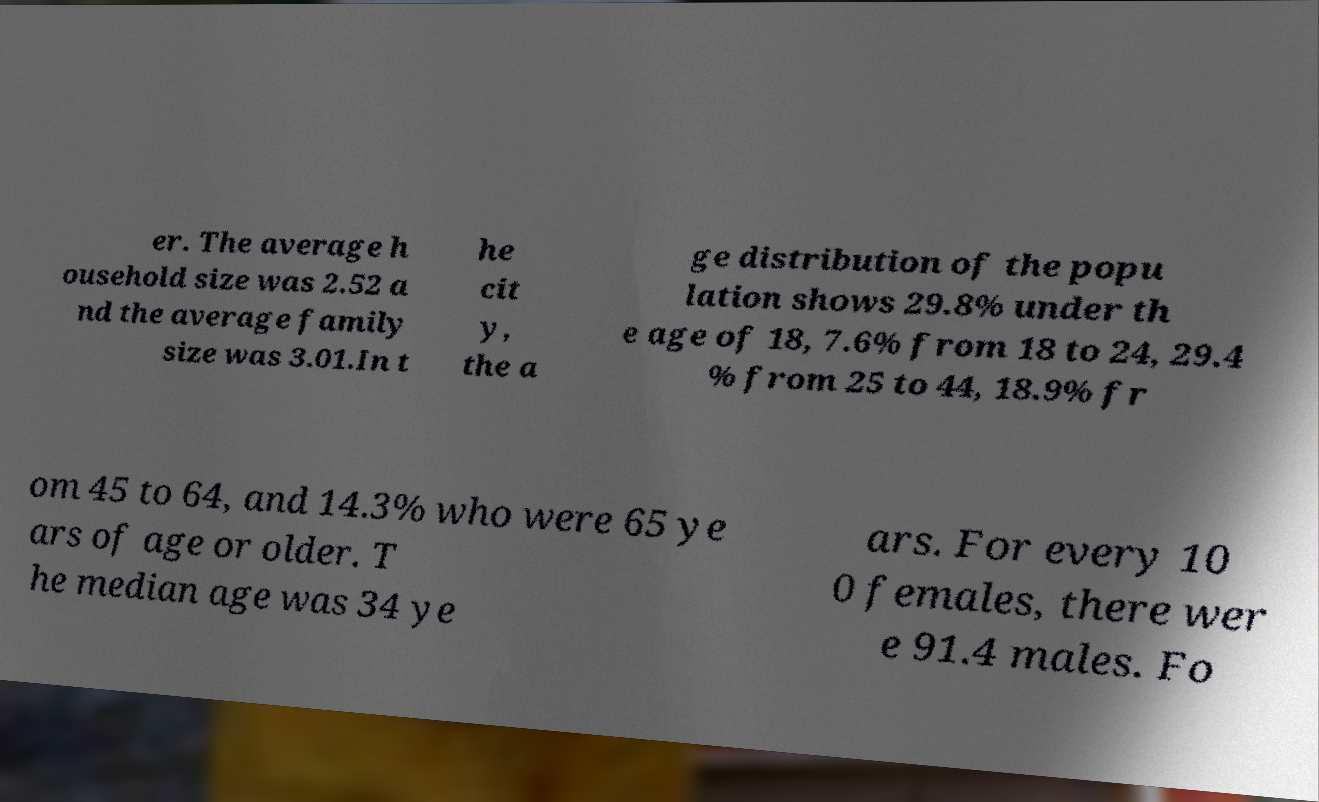Can you read and provide the text displayed in the image?This photo seems to have some interesting text. Can you extract and type it out for me? er. The average h ousehold size was 2.52 a nd the average family size was 3.01.In t he cit y, the a ge distribution of the popu lation shows 29.8% under th e age of 18, 7.6% from 18 to 24, 29.4 % from 25 to 44, 18.9% fr om 45 to 64, and 14.3% who were 65 ye ars of age or older. T he median age was 34 ye ars. For every 10 0 females, there wer e 91.4 males. Fo 